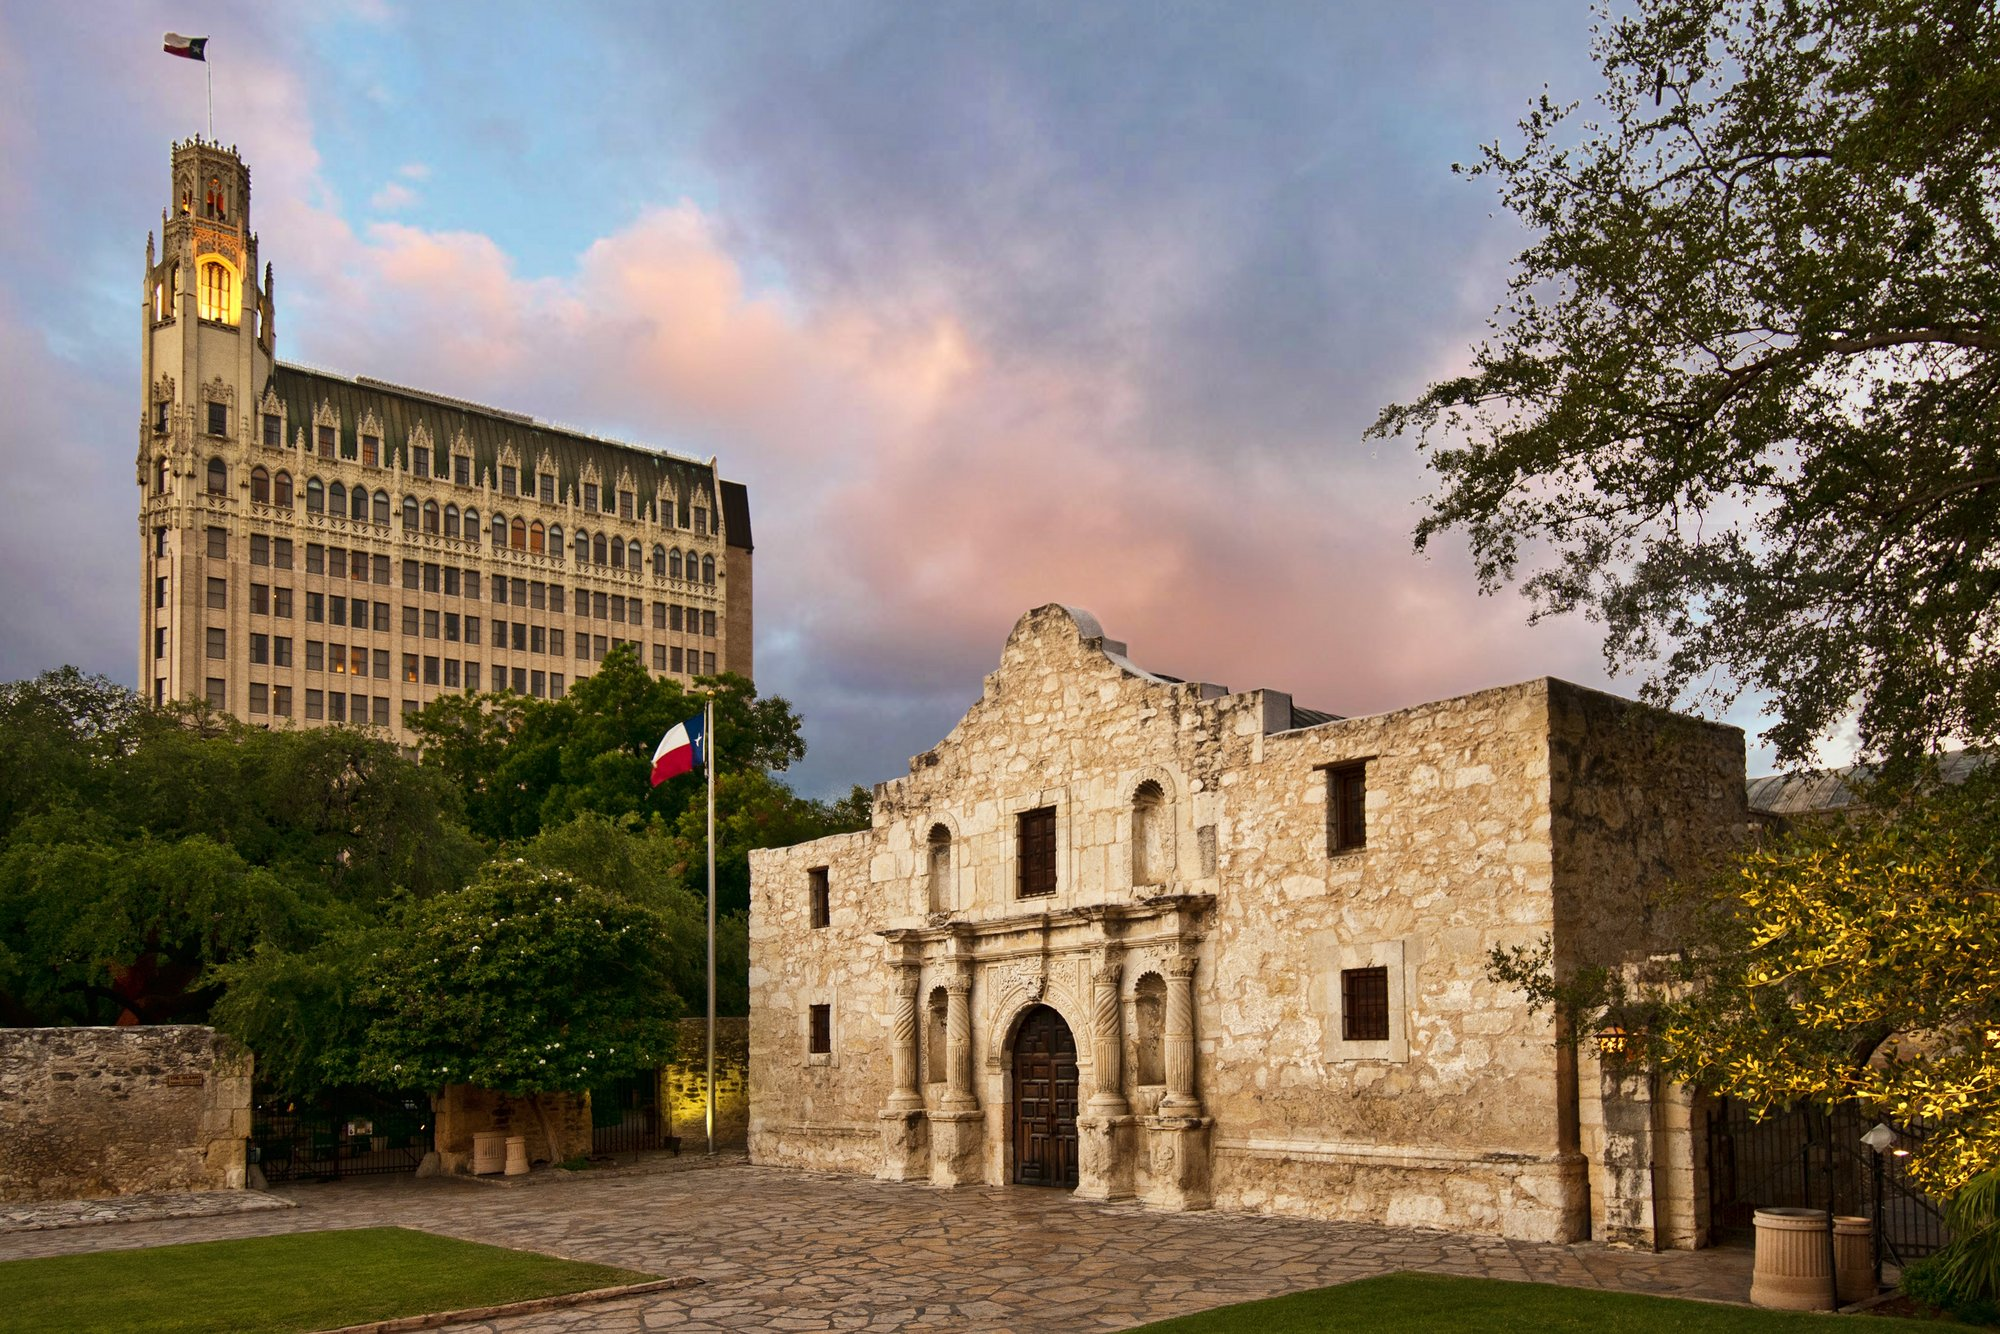Write a detailed description of the given image. The image captures the iconic Alamo, a historic landmark situated in San Antonio, Texas. The Alamo's prominent beige stone facade, known for its distinctive shape and intricate carvings, stands out in the foreground. Its historic, wooden doors are closed, adding to the sense of antiquity. Surrounding this historic structure are lush green trees that add a touch of nature to the scene. The Texas flag is prominently displayed on a flagpole near the Alamo, fluttering in the gentle breeze. The perspective of the photograph is slightly angled upward, which enhances the grandeur and importance of the Alamo. In the background, a stately building with a clock tower rises above, showcasing a blend of historic and modern architecture. The sky above is captivating, painted in beautiful hues of pink and blue with scattered fluffy clouds, creating a serene and picturesque ambiance. The image effectively highlights the architectural beauty and historic significance of the Alamo, juxtaposed with the modern elements of the surrounding structures. 